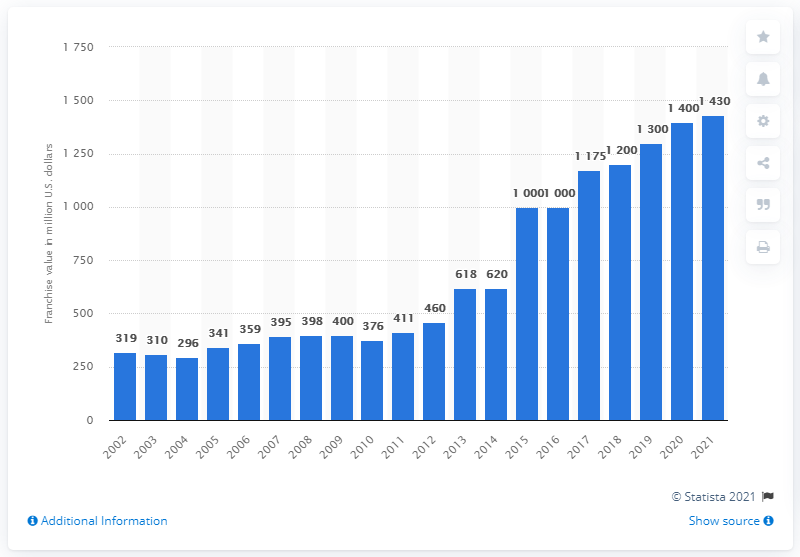Give some essential details in this illustration. In 2021, the estimated value of the Baltimore Orioles was calculated to be 1,430. 